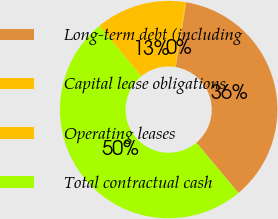Convert chart to OTSL. <chart><loc_0><loc_0><loc_500><loc_500><pie_chart><fcel>Long-term debt (including<fcel>Capital lease obligations<fcel>Operating leases<fcel>Total contractual cash<nl><fcel>36.34%<fcel>0.13%<fcel>13.43%<fcel>50.11%<nl></chart> 